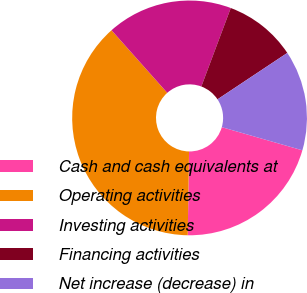<chart> <loc_0><loc_0><loc_500><loc_500><pie_chart><fcel>Cash and cash equivalents at<fcel>Operating activities<fcel>Investing activities<fcel>Financing activities<fcel>Net increase (decrease) in<nl><fcel>20.8%<fcel>38.18%<fcel>17.29%<fcel>9.95%<fcel>13.79%<nl></chart> 